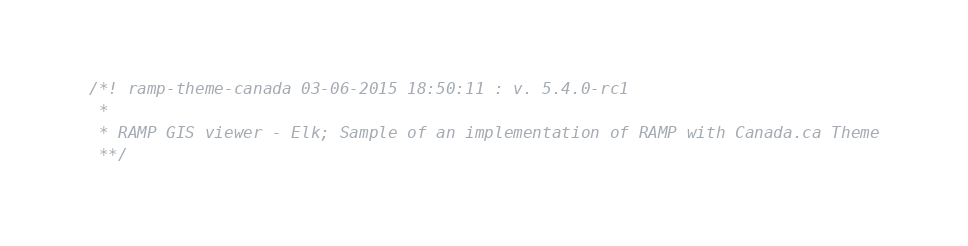<code> <loc_0><loc_0><loc_500><loc_500><_JavaScript_>/*! ramp-theme-canada 03-06-2015 18:50:11 : v. 5.4.0-rc1 
 * 
 * RAMP GIS viewer - Elk; Sample of an implementation of RAMP with Canada.ca Theme 
 **/</code> 